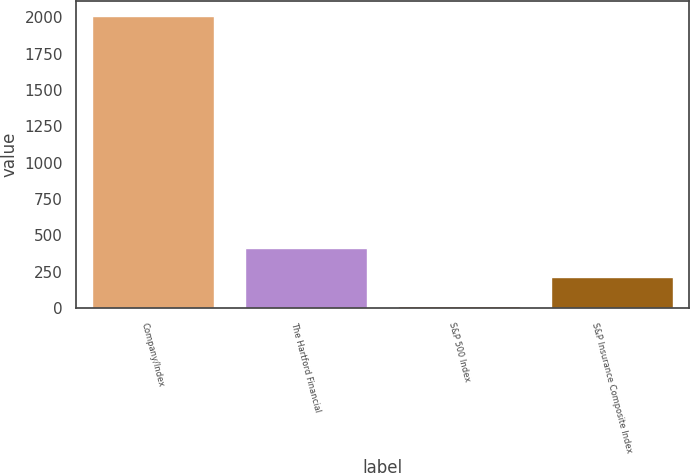<chart> <loc_0><loc_0><loc_500><loc_500><bar_chart><fcel>Company/Index<fcel>The Hartford Financial<fcel>S&P 500 Index<fcel>S&P Insurance Composite Index<nl><fcel>2012<fcel>415.2<fcel>16<fcel>215.6<nl></chart> 